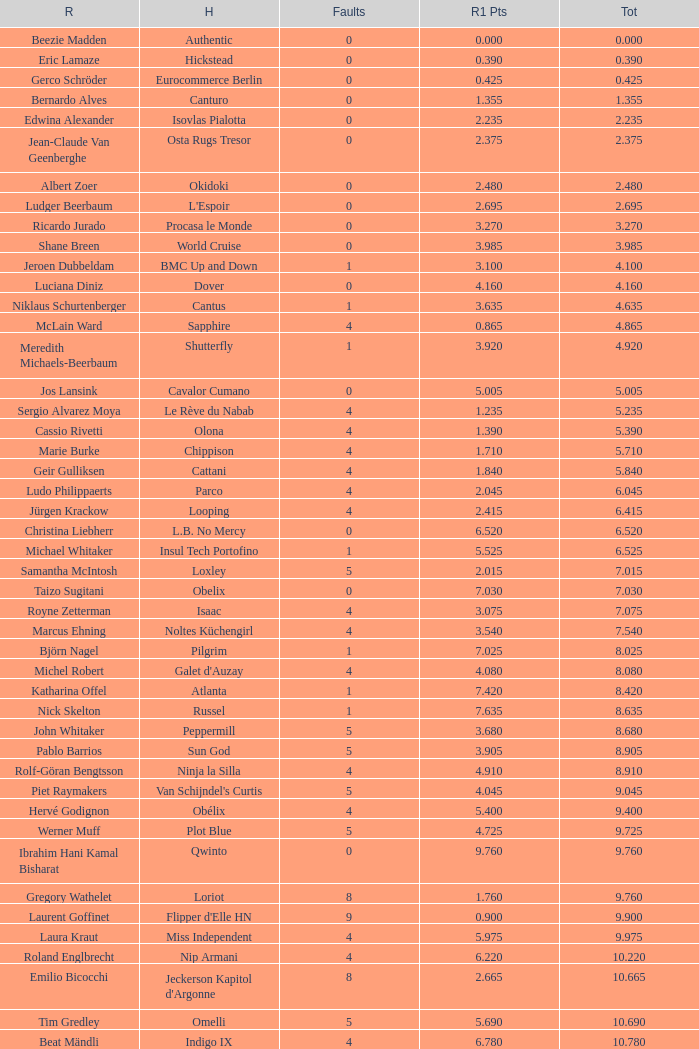Tell me the rider that had round 1 points of 7.465 and total more than 16.615 Manuel Fernandez Saro. Can you give me this table as a dict? {'header': ['R', 'H', 'Faults', 'R1 Pts', 'Tot'], 'rows': [['Beezie Madden', 'Authentic', '0', '0.000', '0.000'], ['Eric Lamaze', 'Hickstead', '0', '0.390', '0.390'], ['Gerco Schröder', 'Eurocommerce Berlin', '0', '0.425', '0.425'], ['Bernardo Alves', 'Canturo', '0', '1.355', '1.355'], ['Edwina Alexander', 'Isovlas Pialotta', '0', '2.235', '2.235'], ['Jean-Claude Van Geenberghe', 'Osta Rugs Tresor', '0', '2.375', '2.375'], ['Albert Zoer', 'Okidoki', '0', '2.480', '2.480'], ['Ludger Beerbaum', "L'Espoir", '0', '2.695', '2.695'], ['Ricardo Jurado', 'Procasa le Monde', '0', '3.270', '3.270'], ['Shane Breen', 'World Cruise', '0', '3.985', '3.985'], ['Jeroen Dubbeldam', 'BMC Up and Down', '1', '3.100', '4.100'], ['Luciana Diniz', 'Dover', '0', '4.160', '4.160'], ['Niklaus Schurtenberger', 'Cantus', '1', '3.635', '4.635'], ['McLain Ward', 'Sapphire', '4', '0.865', '4.865'], ['Meredith Michaels-Beerbaum', 'Shutterfly', '1', '3.920', '4.920'], ['Jos Lansink', 'Cavalor Cumano', '0', '5.005', '5.005'], ['Sergio Alvarez Moya', 'Le Rève du Nabab', '4', '1.235', '5.235'], ['Cassio Rivetti', 'Olona', '4', '1.390', '5.390'], ['Marie Burke', 'Chippison', '4', '1.710', '5.710'], ['Geir Gulliksen', 'Cattani', '4', '1.840', '5.840'], ['Ludo Philippaerts', 'Parco', '4', '2.045', '6.045'], ['Jürgen Krackow', 'Looping', '4', '2.415', '6.415'], ['Christina Liebherr', 'L.B. No Mercy', '0', '6.520', '6.520'], ['Michael Whitaker', 'Insul Tech Portofino', '1', '5.525', '6.525'], ['Samantha McIntosh', 'Loxley', '5', '2.015', '7.015'], ['Taizo Sugitani', 'Obelix', '0', '7.030', '7.030'], ['Royne Zetterman', 'Isaac', '4', '3.075', '7.075'], ['Marcus Ehning', 'Noltes Küchengirl', '4', '3.540', '7.540'], ['Björn Nagel', 'Pilgrim', '1', '7.025', '8.025'], ['Michel Robert', "Galet d'Auzay", '4', '4.080', '8.080'], ['Katharina Offel', 'Atlanta', '1', '7.420', '8.420'], ['Nick Skelton', 'Russel', '1', '7.635', '8.635'], ['John Whitaker', 'Peppermill', '5', '3.680', '8.680'], ['Pablo Barrios', 'Sun God', '5', '3.905', '8.905'], ['Rolf-Göran Bengtsson', 'Ninja la Silla', '4', '4.910', '8.910'], ['Piet Raymakers', "Van Schijndel's Curtis", '5', '4.045', '9.045'], ['Hervé Godignon', 'Obélix', '4', '5.400', '9.400'], ['Werner Muff', 'Plot Blue', '5', '4.725', '9.725'], ['Ibrahim Hani Kamal Bisharat', 'Qwinto', '0', '9.760', '9.760'], ['Gregory Wathelet', 'Loriot', '8', '1.760', '9.760'], ['Laurent Goffinet', "Flipper d'Elle HN", '9', '0.900', '9.900'], ['Laura Kraut', 'Miss Independent', '4', '5.975', '9.975'], ['Roland Englbrecht', 'Nip Armani', '4', '6.220', '10.220'], ['Emilio Bicocchi', "Jeckerson Kapitol d'Argonne", '8', '2.665', '10.665'], ['Tim Gredley', 'Omelli', '5', '5.690', '10.690'], ['Beat Mändli', 'Indigo IX', '4', '6.780', '10.780'], ['Christian Ahlmann', 'Cöster', '8', '4.000', '12.000'], ['Tina Lund', 'Carola', '9', '3.610', '12.610'], ['Max Amaya', 'Church Road', '8', '4.790', '12.790'], ['Álvaro Alfonso de Miranda Neto', 'Nike', '9', '4.235', '13.235'], ['Jesus Garmendia Echeverria', 'Maddock', '8', '5.335', '13.335'], ['Carlos Lopez', 'Instit', '10', '3.620', '13.620'], ['Juan Carlos García', 'Loro Piana Albin III', '5', '9.020', '14.020'], ['Cameron Hanley', 'Siec Hippica Kerman', '9', '5.375', '14.375'], ['Ricardo Kierkegaard', 'Rey Z', '8', '6.805', '14.805'], ['Jill Henselwood', 'Special Ed', '9', '6.165', '15.165'], ['Margie Engle', "Hidden Creek's Quervo Gold", '4', '12.065', '16.065'], ['Judy-Ann Melchoir', 'Grande Dame Z', '9', '7.310', '16.310'], ['Maria Gretzer', 'Spender S', '9', '7.385', '16.385'], ['Billy Twomey', 'Luidam', '9', '7.615', '16.615'], ['Federico Fernandez', 'Bohemio', '8', '9.610', '17.610'], ['Jonella Ligresti', 'Quinta 27', '6', '12.365', '18.365'], ['Ian Millar', 'In Style', '9', '9.370', '18.370'], ['Mikael Forsten', "BMC's Skybreaker", '12', '6.435', '18.435'], ['Sebastian Numminen', 'Sails Away', '13', '5.455', '18.455'], ['Stefan Eder', 'Cartier PSG', '12', '6.535', '18.535'], ['Dirk Demeersman', 'Clinton', '16', '2.755', '18.755'], ['Antonis Petris', 'Gredo la Daviere', '13', '6.300', '19.300'], ['Gunnar Klettenberg', 'Novesta', '9', '10.620', '19.620'], ['Syed Omar Almohdzar', 'Lui', '10', '9.820', '19.820'], ['Tony Andre Hansen', 'Camiro', '13', '7.245', '20.245'], ['Manuel Fernandez Saro', 'Quin Chin', '13', '7.465', '20.465'], ['James Wingrave', 'Agropoint Calira', '14', '6.855', '20.855'], ['Rod Brown', 'Mr. Burns', '9', '12.300', '21.300'], ['Jiri Papousek', 'La Manche T', '13', '8.440', '21.440'], ['Marcela Lobo', 'Joskin', '14', '7.600', '21.600'], ['Yuko Itakura', 'Portvliet', '9', '12.655', '21.655'], ['Zsolt Pirik', 'Havanna', '9', '13.050', '22.050'], ['Fabrice Lyon', 'Jasmine du Perron', '11', '12.760', '23.760'], ['Florian Angot', 'First de Launay', '16', '8.055', '24.055'], ['Peter McMahon', 'Kolora Stud Genoa', '9', '15.195', '24.195'], ['Giuseppe Rolli', 'Jericho de la Vie', '17', '7.910', '24.910'], ['Alberto Michan', 'Chinobampo Lavita', '13', '12.330', '25.330'], ['Hanno Ellermann', 'Poncorde', '17', '8.600', '25.600'], ['Antonio Portela Carneiro', 'Echo de Lessay', '18', '8.565', '26.565'], ['Gerfried Puck', '11th Bleeker', '21', '6.405', '27.405'], ['H.H. Prince Faisal Al-Shalan', 'Uthago', '18', '10.205', '28.205'], ['Vladimir Beletskiy', 'Rezonanz', '21', '7.725', '28.725'], ['Noora Pentti', 'Evli Cagliostro', '17', '12.455', '29.455'], ['Mohammed Al-Kumaiti', 'Al-Mutawakel', '17', '12.490', '29.490'], ['Guillermo Obligado', 'Carlson', '18', '11.545', '29.545'], ['Kamal Bahamdan', 'Campus', '17', '13.190', '30.190'], ['Veronika Macanova', 'Pompos', '13', '18.185', '31.185'], ['Vladimir Panchenko', 'Lanteno', '17', '14.460', '31.460'], ['Jose Larocca', 'Svante', '25', '8.190', '33.190'], ['Abdullah Al-Sharbatly', 'Hugo Gesmeray', '25', '8.585', '33.585'], ['Eiken Sato', 'Cayak DH', '17', '17.960', '34.960'], ['Gennadiy Gashiboyazov', 'Papirus', '28', '8.685', '36.685'], ['Karim El-Zoghby', 'Baragway', '21', '16.360', '37.360'], ['Ondrej Nagr', 'Atlas', '19', '19.865', '38.865'], ['Roger Hessen', 'Quito', '23', '17.410', '40.410'], ['Zdenek Zila', 'Pinot Grigio', '15', '26.035', '41.035'], ['Rene Lopez', 'Isky', '30', '11.675', '41.675'], ['Emmanouela Athanassiades', 'Rimini Z', '18', '24.380', '42.380'], ['Jamie Kermond', 'Stylish King', '21', '46.035', '67.035'], ['Malin Baryard-Johnsson', 'Butterfly Flip', '29', '46.035', '75.035'], ['Manuel Torres', 'Chambacunero', 'Fall', 'Fall', '5.470'], ['Krzyszlof Ludwiczak', 'HOF Schretstakens Quamiro', 'Eliminated', 'Eliminated', '7.460'], ['Grant Wilson', 'Up and Down Cellebroedersbos', 'Refusal', 'Refusal', '14.835'], ['Chris Pratt', 'Rivendell', 'Fall', 'Fall', '15.220'], ['Ariana Azcarraga', 'Sambo', 'Eliminated', 'Eliminated', '15.945'], ['Jose Alfredo Hernandez Ortega', 'Semtex P', 'Eliminated', 'Eliminated', '46.035'], ['H.R.H. Prince Abdullah Al-Soud', 'Allah Jabek', 'Retired', 'Retired', '46.035']]} 